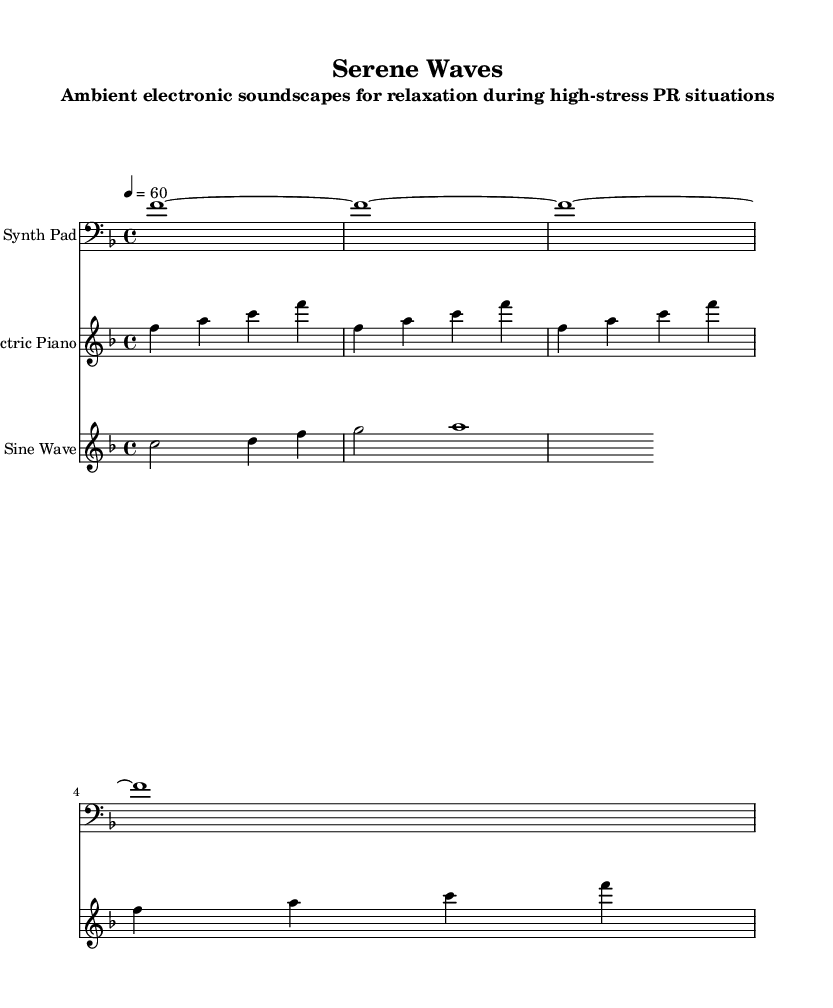What is the key signature of this music? The key signature is F major, which has one flat (B flat). We can tell this from the key signature marking at the beginning of the staff.
Answer: F major What is the time signature of this music? The time signature is 4/4, indicated at the beginning of the score. It shows that there are four beats in each measure and the quarter note gets one beat.
Answer: 4/4 What is the tempo marking of this piece? The tempo marking is 60 beats per minute, specified below the clef at the start of the score. It indicates the speed at which the piece should be performed.
Answer: 60 How many measures are in the Synth Pad part? There are four measures in the Synth Pad part, which can be counted by looking at the distinct groups of vertical lines (bar lines) separating the segments in the staff.
Answer: 4 What instruments are used in this composition? The instruments used are Synth Pad, Electric Piano, and Soft Sine Wave, as indicated at the beginning of each respective staff in the score.
Answer: Synth Pad, Electric Piano, Soft Sine Wave What type of electronic music does this composition represent? This composition represents ambient electronic soundscapes, characterized by their soothing and atmospheric qualities, which are directly suggested by the title and arrangement.
Answer: Ambient electronic 